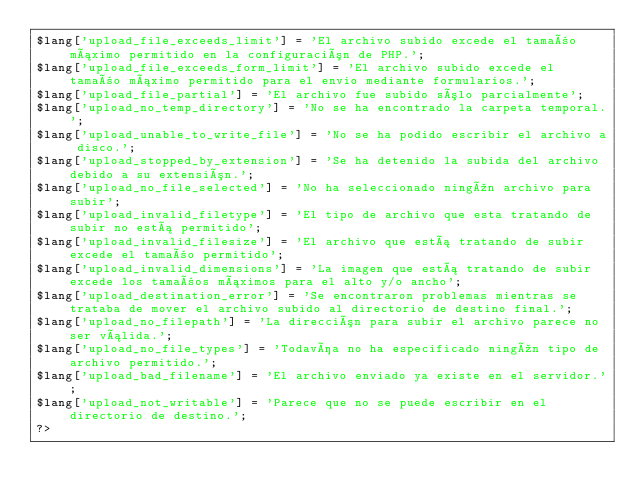<code> <loc_0><loc_0><loc_500><loc_500><_PHP_>$lang['upload_file_exceeds_limit'] = 'El archivo subido excede el tamaño máximo permitido en la configuración de PHP.';
$lang['upload_file_exceeds_form_limit'] = 'El archivo subido excede el tamaño máximo permitido para el envio mediante formularios.';
$lang['upload_file_partial'] = 'El archivo fue subido sólo parcialmente';
$lang['upload_no_temp_directory'] = 'No se ha encontrado la carpeta temporal.';
$lang['upload_unable_to_write_file'] = 'No se ha podido escribir el archivo a disco.';
$lang['upload_stopped_by_extension'] = 'Se ha detenido la subida del archivo debido a su extensión.';
$lang['upload_no_file_selected'] = 'No ha seleccionado ningún archivo para subir';
$lang['upload_invalid_filetype'] = 'El tipo de archivo que esta tratando de subir no está permitido';
$lang['upload_invalid_filesize'] = 'El archivo que está tratando de subir excede el tamaño permitido';
$lang['upload_invalid_dimensions'] = 'La imagen que está tratando de subir excede los tamaños máximos para el alto y/o ancho';
$lang['upload_destination_error'] = 'Se encontraron problemas mientras se trataba de mover el archivo subido al directorio de destino final.';
$lang['upload_no_filepath'] = 'La dirección para subir el archivo parece no ser válida.';
$lang['upload_no_file_types'] = 'Todavía no ha especificado ningún tipo de archivo permitido.';
$lang['upload_bad_filename'] = 'El archivo enviado ya existe en el servidor.';
$lang['upload_not_writable'] = 'Parece que no se puede escribir en el directorio de destino.';
?></code> 